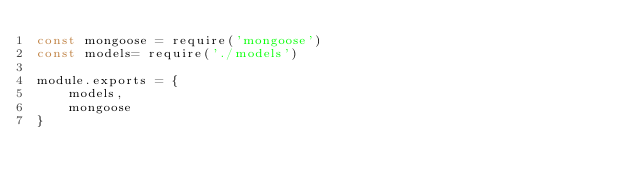<code> <loc_0><loc_0><loc_500><loc_500><_JavaScript_>const mongoose = require('mongoose')
const models= require('./models')

module.exports = {
    models,
    mongoose
}</code> 